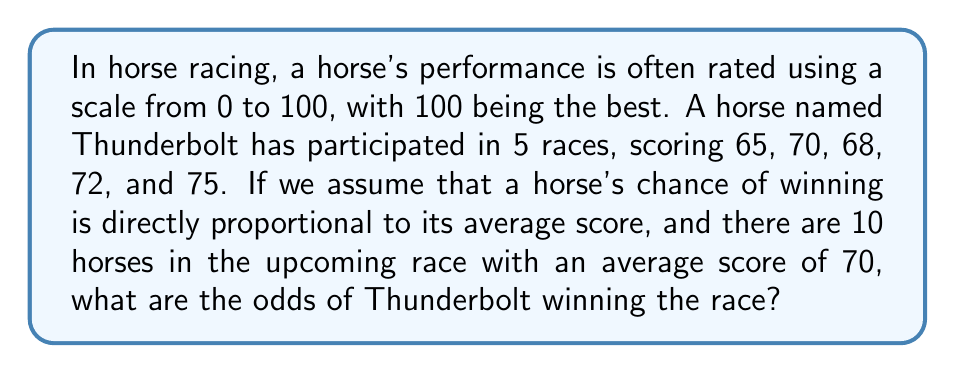Can you answer this question? Let's break this down step-by-step:

1) First, we need to calculate Thunderbolt's average score:
   
   $$ \text{Average} = \frac{65 + 70 + 68 + 72 + 75}{5} = \frac{350}{5} = 70 $$

2) Now, we know that Thunderbolt's average score is 70, which is the same as the average score of all horses in the race.

3) Since the chance of winning is directly proportional to the average score, we can calculate the probability of Thunderbolt winning as:

   $$ P(\text{Thunderbolt wins}) = \frac{\text{Thunderbolt's score}}{\text{Sum of all horses' scores}} $$

4) There are 10 horses in total, each with an average score of 70. So the sum of all scores is:

   $$ 70 \times 10 = 700 $$

5) Therefore, the probability of Thunderbolt winning is:

   $$ P(\text{Thunderbolt wins}) = \frac{70}{700} = \frac{1}{10} = 0.1 $$

6) In horse racing, odds are typically expressed as "X to Y", where X is the amount you would win if you bet Y. This is calculated as:

   $$ \text{Odds} = \frac{1 - P(\text{win})}{P(\text{win})} \text{ to } 1 $$

7) Plugging in our probability:

   $$ \text{Odds} = \frac{1 - 0.1}{0.1} \text{ to } 1 = \frac{0.9}{0.1} \text{ to } 1 = 9 \text{ to } 1 $$
Answer: The odds of Thunderbolt winning the race are 9 to 1. 